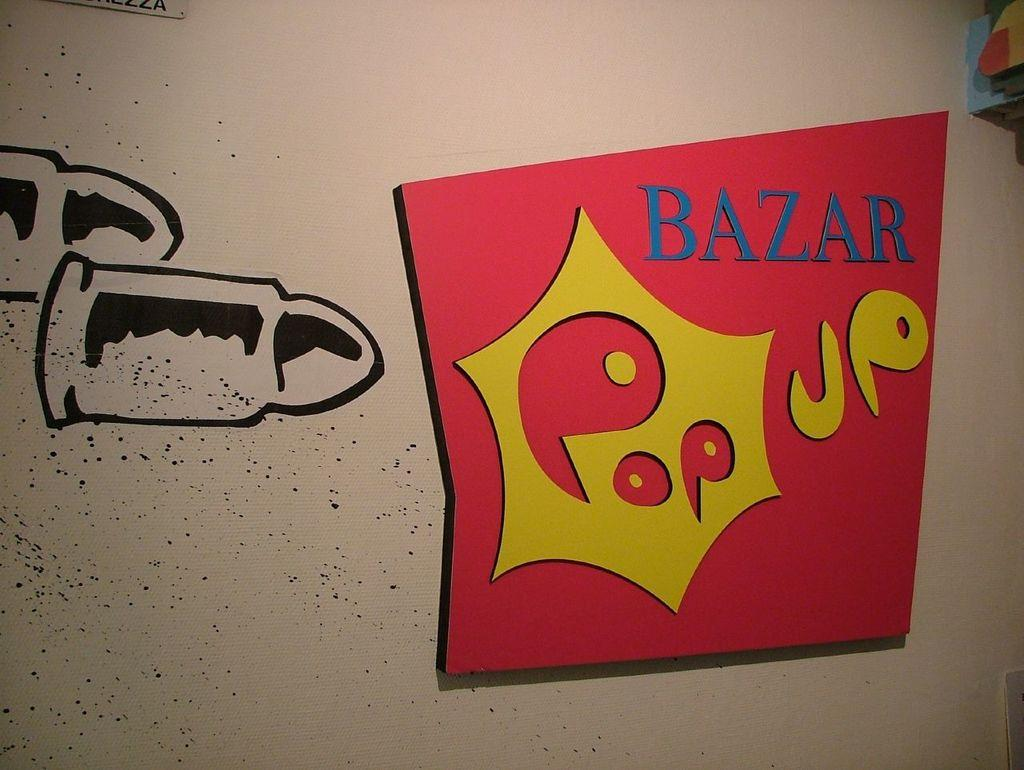<image>
Render a clear and concise summary of the photo. The red sign on the wall says Bazar Pop UP. 